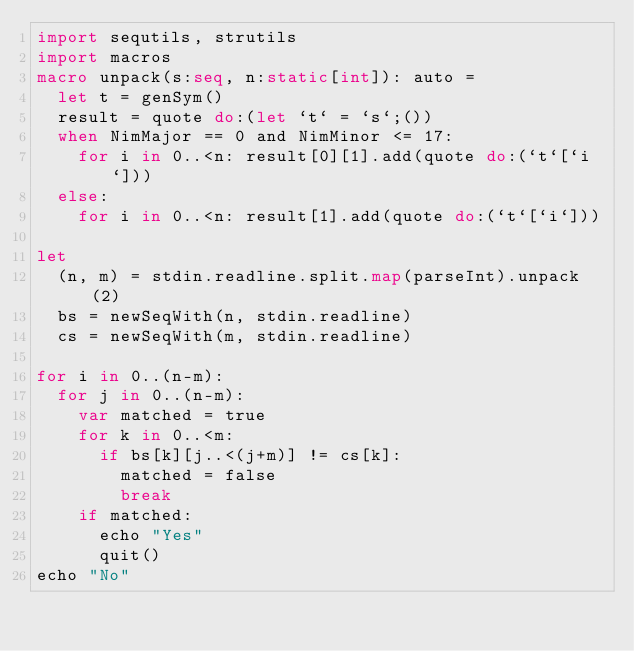Convert code to text. <code><loc_0><loc_0><loc_500><loc_500><_Nim_>import sequtils, strutils
import macros
macro unpack(s:seq, n:static[int]): auto =
  let t = genSym()
  result = quote do:(let `t` = `s`;())
  when NimMajor == 0 and NimMinor <= 17:
    for i in 0..<n: result[0][1].add(quote do:(`t`[`i`]))
  else:
    for i in 0..<n: result[1].add(quote do:(`t`[`i`]))

let
  (n, m) = stdin.readline.split.map(parseInt).unpack(2)
  bs = newSeqWith(n, stdin.readline)
  cs = newSeqWith(m, stdin.readline)

for i in 0..(n-m):
  for j in 0..(n-m):
    var matched = true
    for k in 0..<m:
      if bs[k][j..<(j+m)] != cs[k]:
        matched = false
        break
    if matched:
      echo "Yes"
      quit()
echo "No"
</code> 